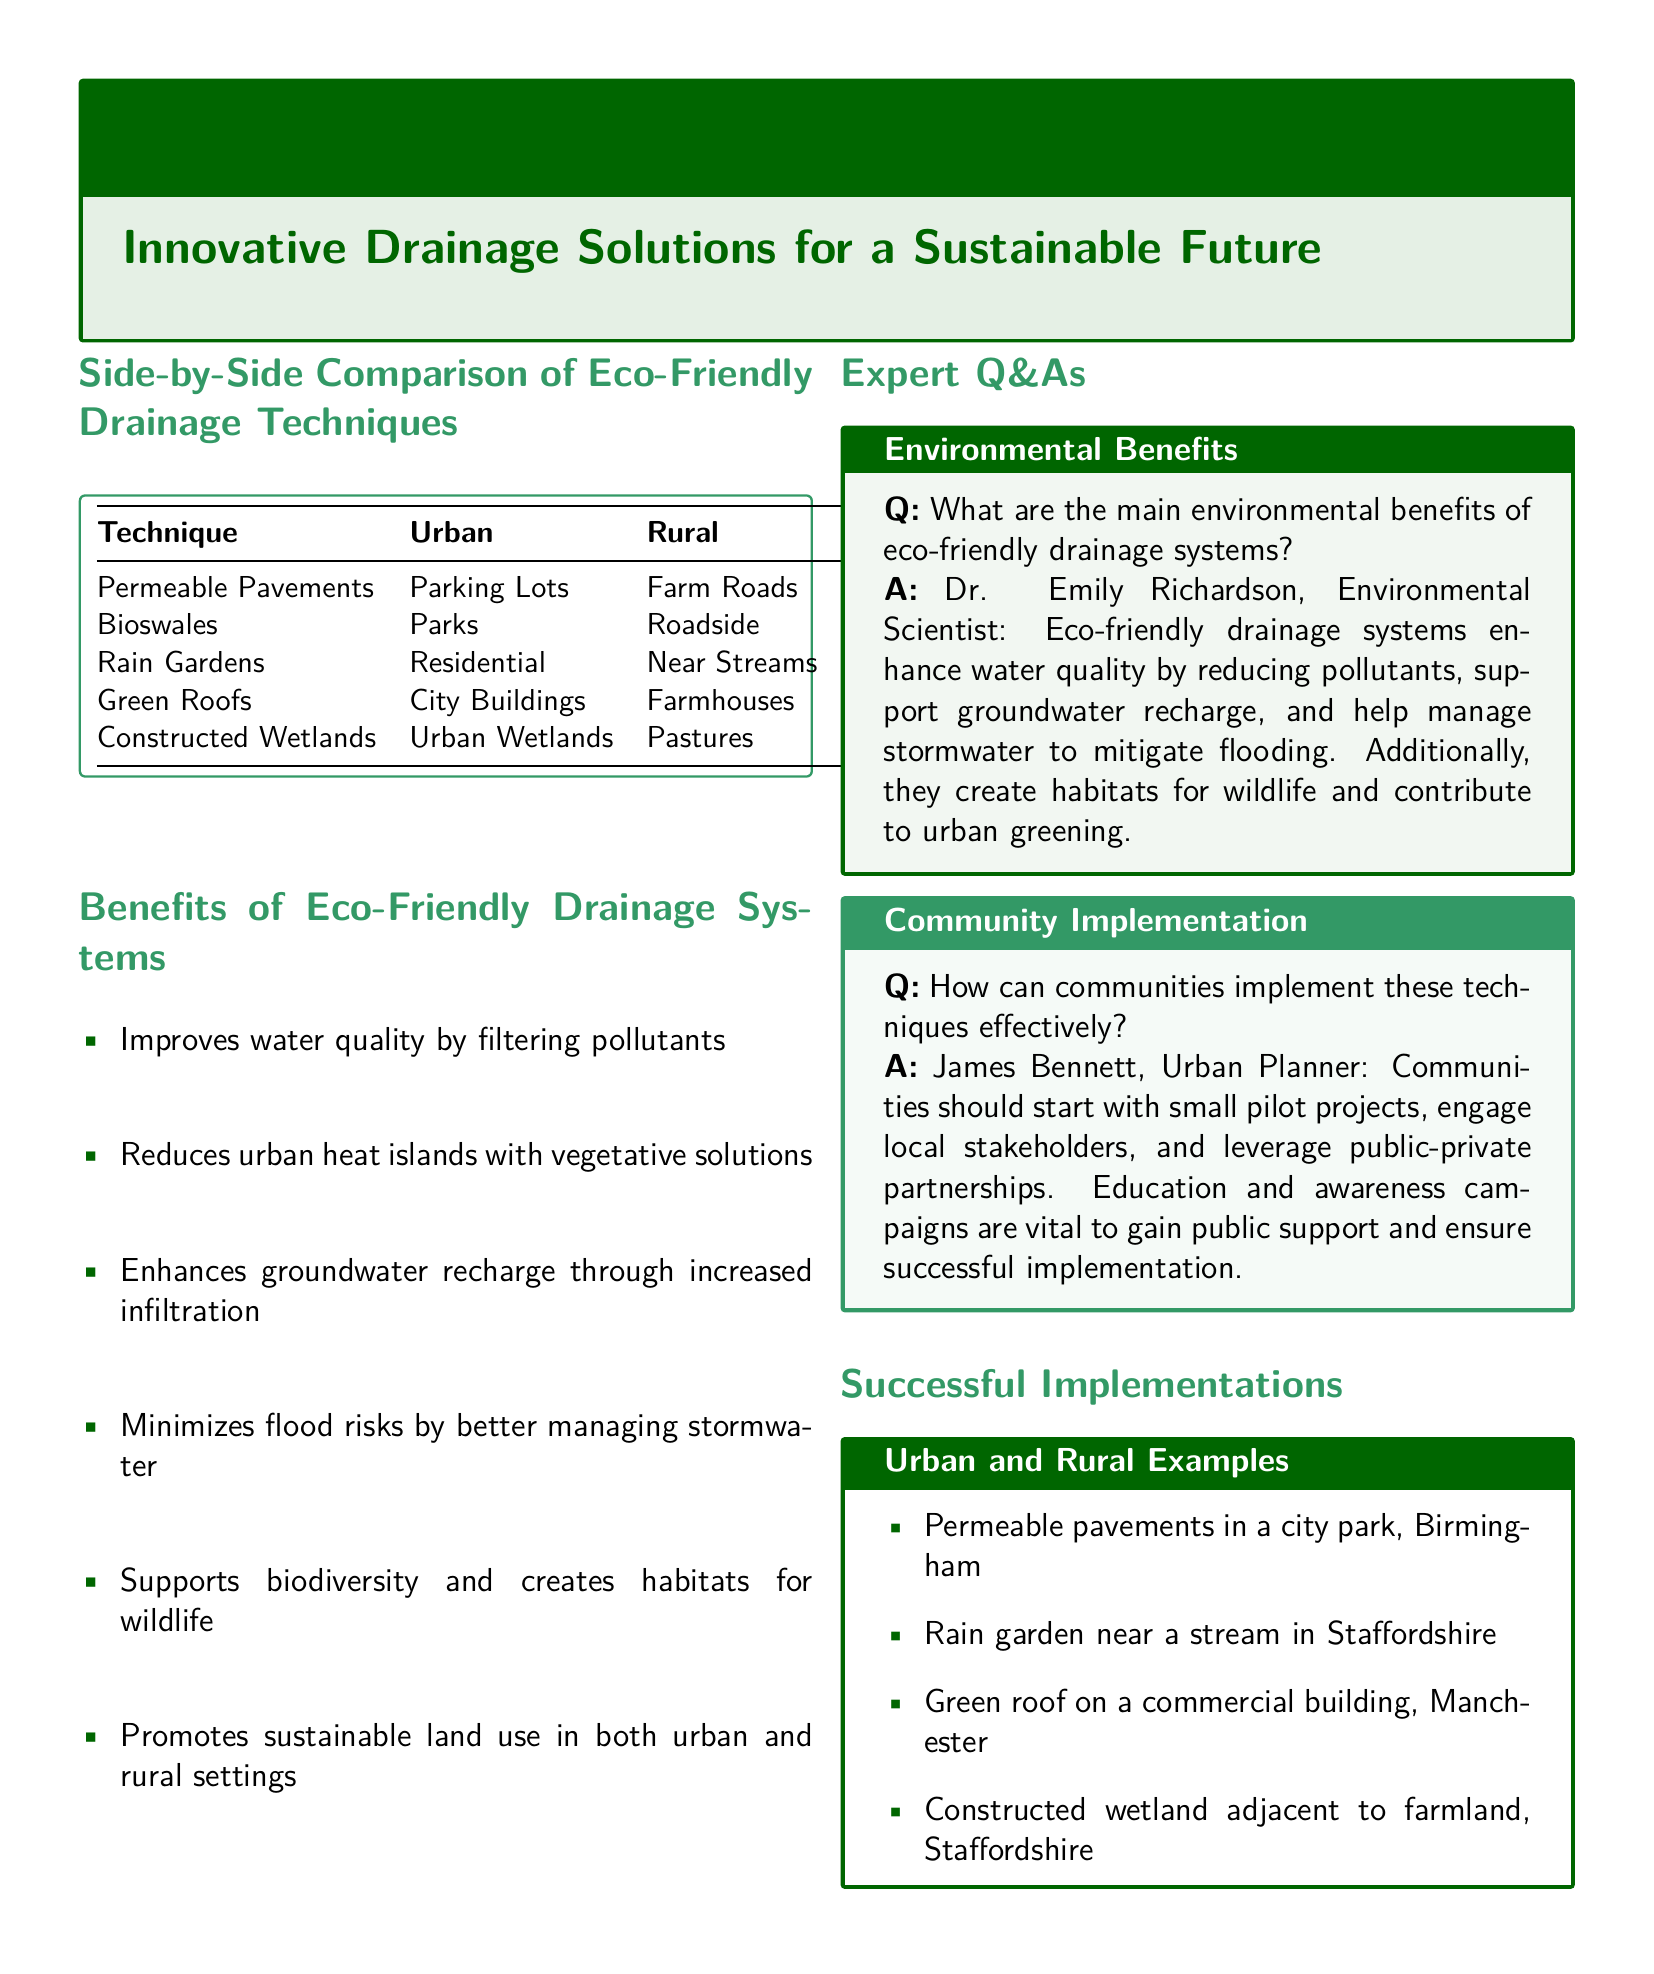What is the technique listed for urban areas that reduces runoff? The document includes permeable pavements as a technique listed for urban areas that reduces runoff.
Answer: Permeable Pavements What is one benefit of eco-friendly drainage systems? The document mentions several benefits of eco-friendly drainage systems, one of which is improving water quality by filtering pollutants.
Answer: Improves water quality Who is the environmental scientist quoted in the document? The document provides the name of an expert, Dr. Emily Richardson, who is an environmental scientist discussing the benefits of eco-friendly systems.
Answer: Dr. Emily Richardson What is a rural technique mentioned in the comparison table? The comparison table lists constructed wetlands as a technique applicable in rural areas.
Answer: Constructed Wetlands Which city features a green roof success example? The successful implementations section of the document mentions a commercial building in Manchester as an example of a green roof.
Answer: Manchester What is emphasized as crucial for community implementation? The document notes that education and awareness campaigns are vital for gaining public support for the effective implementation of eco-friendly drainage techniques.
Answer: Education and awareness campaigns How many eco-friendly drainage techniques are compared in the document? The side-by-side comparison table lists five different eco-friendly drainage techniques used in urban and rural areas.
Answer: Five What habitat benefit is associated with constructed wetlands? The document states that constructed wetlands contribute to habitat creation, which benefits biodiversity.
Answer: Habitat creation 